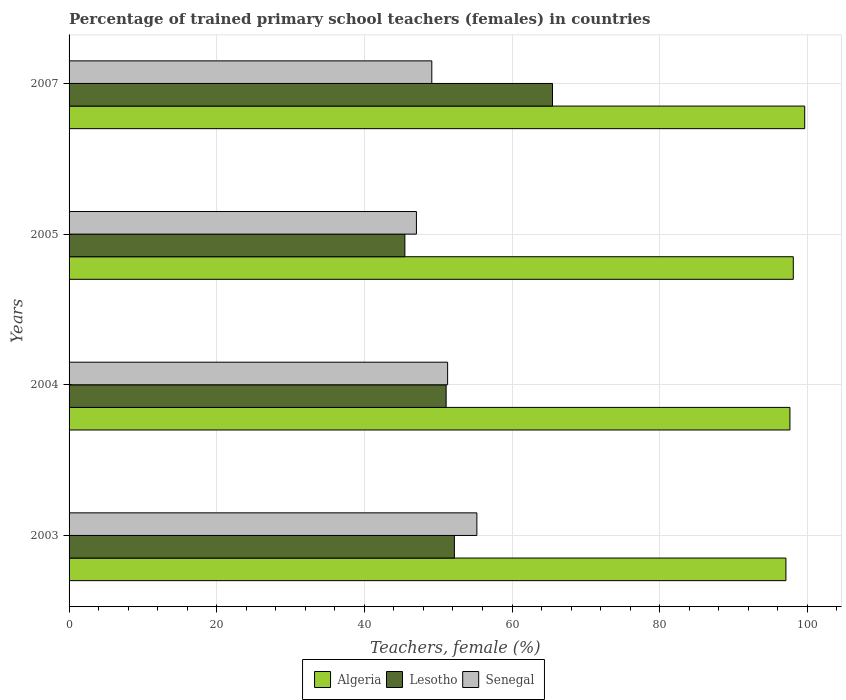How many different coloured bars are there?
Your answer should be very brief. 3. How many bars are there on the 4th tick from the top?
Provide a short and direct response. 3. What is the label of the 2nd group of bars from the top?
Make the answer very short. 2005. In how many cases, is the number of bars for a given year not equal to the number of legend labels?
Give a very brief answer. 0. What is the percentage of trained primary school teachers (females) in Senegal in 2004?
Make the answer very short. 51.28. Across all years, what is the maximum percentage of trained primary school teachers (females) in Algeria?
Your answer should be compact. 99.64. Across all years, what is the minimum percentage of trained primary school teachers (females) in Lesotho?
Your answer should be very brief. 45.48. In which year was the percentage of trained primary school teachers (females) in Senegal maximum?
Provide a short and direct response. 2003. What is the total percentage of trained primary school teachers (females) in Lesotho in the graph?
Make the answer very short. 214.23. What is the difference between the percentage of trained primary school teachers (females) in Lesotho in 2003 and that in 2005?
Ensure brevity in your answer.  6.71. What is the difference between the percentage of trained primary school teachers (females) in Senegal in 2007 and the percentage of trained primary school teachers (females) in Lesotho in 2003?
Make the answer very short. -3.06. What is the average percentage of trained primary school teachers (females) in Lesotho per year?
Your answer should be compact. 53.56. In the year 2007, what is the difference between the percentage of trained primary school teachers (females) in Algeria and percentage of trained primary school teachers (females) in Senegal?
Ensure brevity in your answer.  50.51. In how many years, is the percentage of trained primary school teachers (females) in Lesotho greater than 72 %?
Keep it short and to the point. 0. What is the ratio of the percentage of trained primary school teachers (females) in Lesotho in 2005 to that in 2007?
Make the answer very short. 0.69. Is the difference between the percentage of trained primary school teachers (females) in Algeria in 2005 and 2007 greater than the difference between the percentage of trained primary school teachers (females) in Senegal in 2005 and 2007?
Your answer should be very brief. Yes. What is the difference between the highest and the second highest percentage of trained primary school teachers (females) in Senegal?
Keep it short and to the point. 3.96. What is the difference between the highest and the lowest percentage of trained primary school teachers (females) in Algeria?
Give a very brief answer. 2.55. Is the sum of the percentage of trained primary school teachers (females) in Senegal in 2004 and 2007 greater than the maximum percentage of trained primary school teachers (females) in Algeria across all years?
Make the answer very short. Yes. What does the 2nd bar from the top in 2007 represents?
Give a very brief answer. Lesotho. What does the 1st bar from the bottom in 2003 represents?
Keep it short and to the point. Algeria. How many bars are there?
Your response must be concise. 12. Are all the bars in the graph horizontal?
Your answer should be very brief. Yes. Does the graph contain any zero values?
Your answer should be very brief. No. What is the title of the graph?
Keep it short and to the point. Percentage of trained primary school teachers (females) in countries. What is the label or title of the X-axis?
Offer a terse response. Teachers, female (%). What is the Teachers, female (%) in Algeria in 2003?
Offer a very short reply. 97.1. What is the Teachers, female (%) in Lesotho in 2003?
Give a very brief answer. 52.19. What is the Teachers, female (%) in Senegal in 2003?
Provide a short and direct response. 55.24. What is the Teachers, female (%) in Algeria in 2004?
Provide a succinct answer. 97.64. What is the Teachers, female (%) of Lesotho in 2004?
Your answer should be very brief. 51.07. What is the Teachers, female (%) in Senegal in 2004?
Your response must be concise. 51.28. What is the Teachers, female (%) of Algeria in 2005?
Your answer should be very brief. 98.1. What is the Teachers, female (%) of Lesotho in 2005?
Offer a very short reply. 45.48. What is the Teachers, female (%) of Senegal in 2005?
Offer a terse response. 47.05. What is the Teachers, female (%) of Algeria in 2007?
Offer a very short reply. 99.64. What is the Teachers, female (%) in Lesotho in 2007?
Offer a terse response. 65.48. What is the Teachers, female (%) in Senegal in 2007?
Provide a short and direct response. 49.13. Across all years, what is the maximum Teachers, female (%) in Algeria?
Ensure brevity in your answer.  99.64. Across all years, what is the maximum Teachers, female (%) of Lesotho?
Provide a short and direct response. 65.48. Across all years, what is the maximum Teachers, female (%) of Senegal?
Offer a terse response. 55.24. Across all years, what is the minimum Teachers, female (%) of Algeria?
Provide a short and direct response. 97.1. Across all years, what is the minimum Teachers, female (%) in Lesotho?
Offer a very short reply. 45.48. Across all years, what is the minimum Teachers, female (%) in Senegal?
Your answer should be compact. 47.05. What is the total Teachers, female (%) in Algeria in the graph?
Ensure brevity in your answer.  392.47. What is the total Teachers, female (%) of Lesotho in the graph?
Provide a succinct answer. 214.23. What is the total Teachers, female (%) in Senegal in the graph?
Make the answer very short. 202.69. What is the difference between the Teachers, female (%) of Algeria in 2003 and that in 2004?
Provide a short and direct response. -0.54. What is the difference between the Teachers, female (%) in Lesotho in 2003 and that in 2004?
Your response must be concise. 1.12. What is the difference between the Teachers, female (%) of Senegal in 2003 and that in 2004?
Provide a short and direct response. 3.96. What is the difference between the Teachers, female (%) in Algeria in 2003 and that in 2005?
Make the answer very short. -1. What is the difference between the Teachers, female (%) of Lesotho in 2003 and that in 2005?
Your response must be concise. 6.71. What is the difference between the Teachers, female (%) in Senegal in 2003 and that in 2005?
Provide a succinct answer. 8.19. What is the difference between the Teachers, female (%) in Algeria in 2003 and that in 2007?
Ensure brevity in your answer.  -2.54. What is the difference between the Teachers, female (%) in Lesotho in 2003 and that in 2007?
Keep it short and to the point. -13.29. What is the difference between the Teachers, female (%) of Senegal in 2003 and that in 2007?
Your response must be concise. 6.1. What is the difference between the Teachers, female (%) of Algeria in 2004 and that in 2005?
Offer a terse response. -0.46. What is the difference between the Teachers, female (%) in Lesotho in 2004 and that in 2005?
Provide a succinct answer. 5.59. What is the difference between the Teachers, female (%) of Senegal in 2004 and that in 2005?
Offer a terse response. 4.23. What is the difference between the Teachers, female (%) in Algeria in 2004 and that in 2007?
Provide a succinct answer. -2. What is the difference between the Teachers, female (%) of Lesotho in 2004 and that in 2007?
Offer a very short reply. -14.4. What is the difference between the Teachers, female (%) of Senegal in 2004 and that in 2007?
Ensure brevity in your answer.  2.14. What is the difference between the Teachers, female (%) of Algeria in 2005 and that in 2007?
Provide a succinct answer. -1.55. What is the difference between the Teachers, female (%) of Lesotho in 2005 and that in 2007?
Provide a succinct answer. -20. What is the difference between the Teachers, female (%) in Senegal in 2005 and that in 2007?
Offer a very short reply. -2.08. What is the difference between the Teachers, female (%) of Algeria in 2003 and the Teachers, female (%) of Lesotho in 2004?
Make the answer very short. 46.02. What is the difference between the Teachers, female (%) in Algeria in 2003 and the Teachers, female (%) in Senegal in 2004?
Provide a short and direct response. 45.82. What is the difference between the Teachers, female (%) of Lesotho in 2003 and the Teachers, female (%) of Senegal in 2004?
Offer a very short reply. 0.92. What is the difference between the Teachers, female (%) in Algeria in 2003 and the Teachers, female (%) in Lesotho in 2005?
Your response must be concise. 51.61. What is the difference between the Teachers, female (%) of Algeria in 2003 and the Teachers, female (%) of Senegal in 2005?
Offer a very short reply. 50.05. What is the difference between the Teachers, female (%) of Lesotho in 2003 and the Teachers, female (%) of Senegal in 2005?
Provide a short and direct response. 5.14. What is the difference between the Teachers, female (%) of Algeria in 2003 and the Teachers, female (%) of Lesotho in 2007?
Provide a succinct answer. 31.62. What is the difference between the Teachers, female (%) in Algeria in 2003 and the Teachers, female (%) in Senegal in 2007?
Your response must be concise. 47.96. What is the difference between the Teachers, female (%) in Lesotho in 2003 and the Teachers, female (%) in Senegal in 2007?
Ensure brevity in your answer.  3.06. What is the difference between the Teachers, female (%) in Algeria in 2004 and the Teachers, female (%) in Lesotho in 2005?
Your response must be concise. 52.16. What is the difference between the Teachers, female (%) in Algeria in 2004 and the Teachers, female (%) in Senegal in 2005?
Provide a succinct answer. 50.59. What is the difference between the Teachers, female (%) of Lesotho in 2004 and the Teachers, female (%) of Senegal in 2005?
Your answer should be compact. 4.03. What is the difference between the Teachers, female (%) of Algeria in 2004 and the Teachers, female (%) of Lesotho in 2007?
Your answer should be very brief. 32.16. What is the difference between the Teachers, female (%) of Algeria in 2004 and the Teachers, female (%) of Senegal in 2007?
Offer a terse response. 48.51. What is the difference between the Teachers, female (%) in Lesotho in 2004 and the Teachers, female (%) in Senegal in 2007?
Your answer should be compact. 1.94. What is the difference between the Teachers, female (%) of Algeria in 2005 and the Teachers, female (%) of Lesotho in 2007?
Your response must be concise. 32.62. What is the difference between the Teachers, female (%) in Algeria in 2005 and the Teachers, female (%) in Senegal in 2007?
Give a very brief answer. 48.96. What is the difference between the Teachers, female (%) in Lesotho in 2005 and the Teachers, female (%) in Senegal in 2007?
Your answer should be very brief. -3.65. What is the average Teachers, female (%) of Algeria per year?
Your answer should be very brief. 98.12. What is the average Teachers, female (%) in Lesotho per year?
Your response must be concise. 53.56. What is the average Teachers, female (%) in Senegal per year?
Ensure brevity in your answer.  50.67. In the year 2003, what is the difference between the Teachers, female (%) of Algeria and Teachers, female (%) of Lesotho?
Provide a short and direct response. 44.9. In the year 2003, what is the difference between the Teachers, female (%) of Algeria and Teachers, female (%) of Senegal?
Make the answer very short. 41.86. In the year 2003, what is the difference between the Teachers, female (%) in Lesotho and Teachers, female (%) in Senegal?
Give a very brief answer. -3.04. In the year 2004, what is the difference between the Teachers, female (%) of Algeria and Teachers, female (%) of Lesotho?
Your answer should be compact. 46.57. In the year 2004, what is the difference between the Teachers, female (%) in Algeria and Teachers, female (%) in Senegal?
Offer a very short reply. 46.36. In the year 2004, what is the difference between the Teachers, female (%) of Lesotho and Teachers, female (%) of Senegal?
Ensure brevity in your answer.  -0.2. In the year 2005, what is the difference between the Teachers, female (%) of Algeria and Teachers, female (%) of Lesotho?
Your answer should be very brief. 52.61. In the year 2005, what is the difference between the Teachers, female (%) of Algeria and Teachers, female (%) of Senegal?
Your answer should be very brief. 51.05. In the year 2005, what is the difference between the Teachers, female (%) of Lesotho and Teachers, female (%) of Senegal?
Your response must be concise. -1.57. In the year 2007, what is the difference between the Teachers, female (%) in Algeria and Teachers, female (%) in Lesotho?
Your answer should be compact. 34.16. In the year 2007, what is the difference between the Teachers, female (%) of Algeria and Teachers, female (%) of Senegal?
Provide a short and direct response. 50.51. In the year 2007, what is the difference between the Teachers, female (%) of Lesotho and Teachers, female (%) of Senegal?
Your answer should be very brief. 16.35. What is the ratio of the Teachers, female (%) in Algeria in 2003 to that in 2004?
Your answer should be very brief. 0.99. What is the ratio of the Teachers, female (%) of Lesotho in 2003 to that in 2004?
Ensure brevity in your answer.  1.02. What is the ratio of the Teachers, female (%) in Senegal in 2003 to that in 2004?
Ensure brevity in your answer.  1.08. What is the ratio of the Teachers, female (%) of Lesotho in 2003 to that in 2005?
Provide a short and direct response. 1.15. What is the ratio of the Teachers, female (%) in Senegal in 2003 to that in 2005?
Your response must be concise. 1.17. What is the ratio of the Teachers, female (%) in Algeria in 2003 to that in 2007?
Offer a very short reply. 0.97. What is the ratio of the Teachers, female (%) of Lesotho in 2003 to that in 2007?
Make the answer very short. 0.8. What is the ratio of the Teachers, female (%) of Senegal in 2003 to that in 2007?
Make the answer very short. 1.12. What is the ratio of the Teachers, female (%) of Lesotho in 2004 to that in 2005?
Your answer should be compact. 1.12. What is the ratio of the Teachers, female (%) in Senegal in 2004 to that in 2005?
Give a very brief answer. 1.09. What is the ratio of the Teachers, female (%) in Algeria in 2004 to that in 2007?
Your answer should be very brief. 0.98. What is the ratio of the Teachers, female (%) in Lesotho in 2004 to that in 2007?
Offer a very short reply. 0.78. What is the ratio of the Teachers, female (%) in Senegal in 2004 to that in 2007?
Ensure brevity in your answer.  1.04. What is the ratio of the Teachers, female (%) of Algeria in 2005 to that in 2007?
Offer a very short reply. 0.98. What is the ratio of the Teachers, female (%) of Lesotho in 2005 to that in 2007?
Offer a very short reply. 0.69. What is the ratio of the Teachers, female (%) of Senegal in 2005 to that in 2007?
Give a very brief answer. 0.96. What is the difference between the highest and the second highest Teachers, female (%) in Algeria?
Offer a very short reply. 1.55. What is the difference between the highest and the second highest Teachers, female (%) of Lesotho?
Keep it short and to the point. 13.29. What is the difference between the highest and the second highest Teachers, female (%) in Senegal?
Give a very brief answer. 3.96. What is the difference between the highest and the lowest Teachers, female (%) in Algeria?
Your answer should be very brief. 2.54. What is the difference between the highest and the lowest Teachers, female (%) of Lesotho?
Provide a succinct answer. 20. What is the difference between the highest and the lowest Teachers, female (%) of Senegal?
Your answer should be very brief. 8.19. 